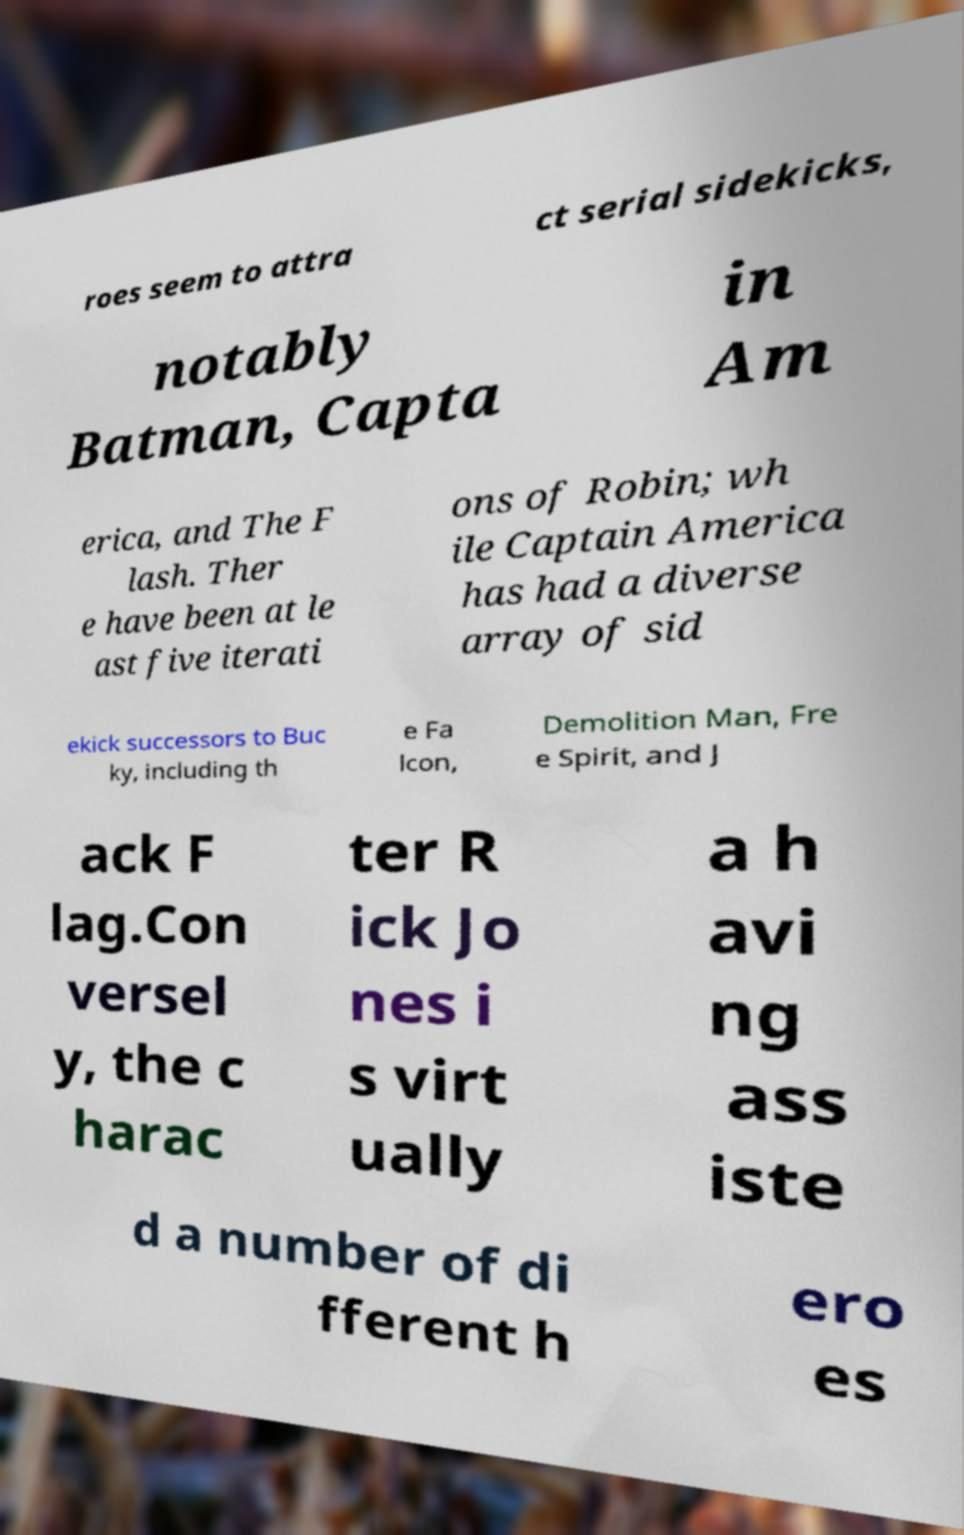I need the written content from this picture converted into text. Can you do that? roes seem to attra ct serial sidekicks, notably Batman, Capta in Am erica, and The F lash. Ther e have been at le ast five iterati ons of Robin; wh ile Captain America has had a diverse array of sid ekick successors to Buc ky, including th e Fa lcon, Demolition Man, Fre e Spirit, and J ack F lag.Con versel y, the c harac ter R ick Jo nes i s virt ually a h avi ng ass iste d a number of di fferent h ero es 